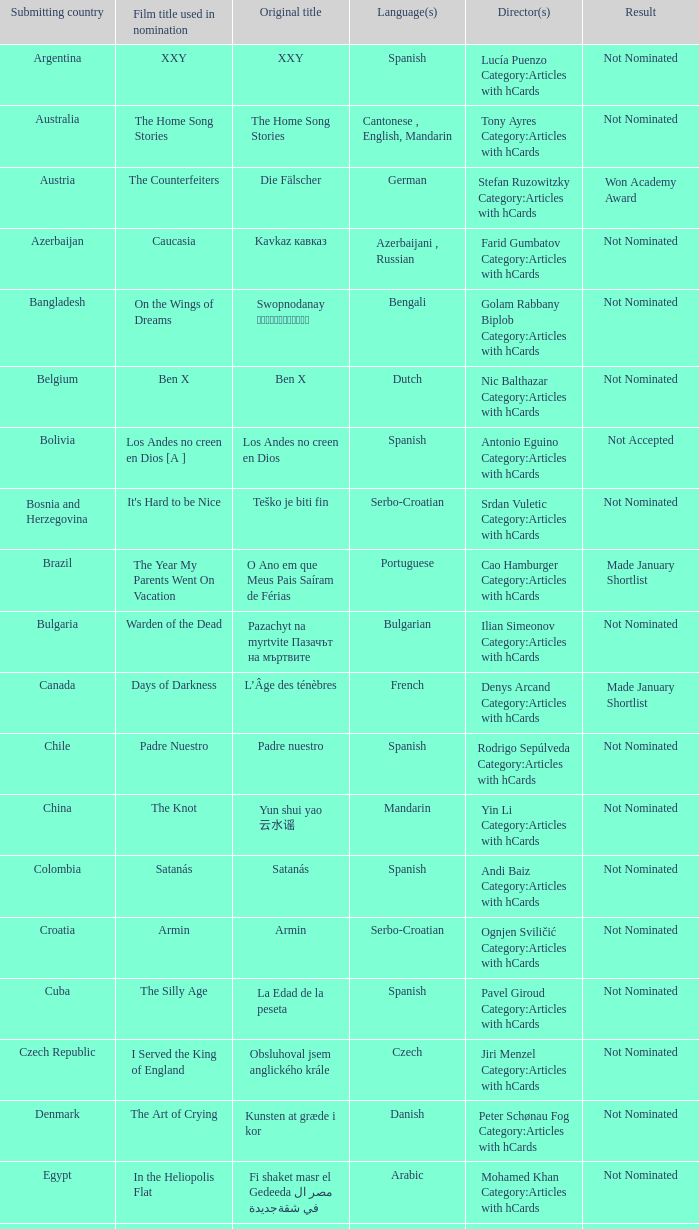What was the title of the movie from lebanon? Caramel. 